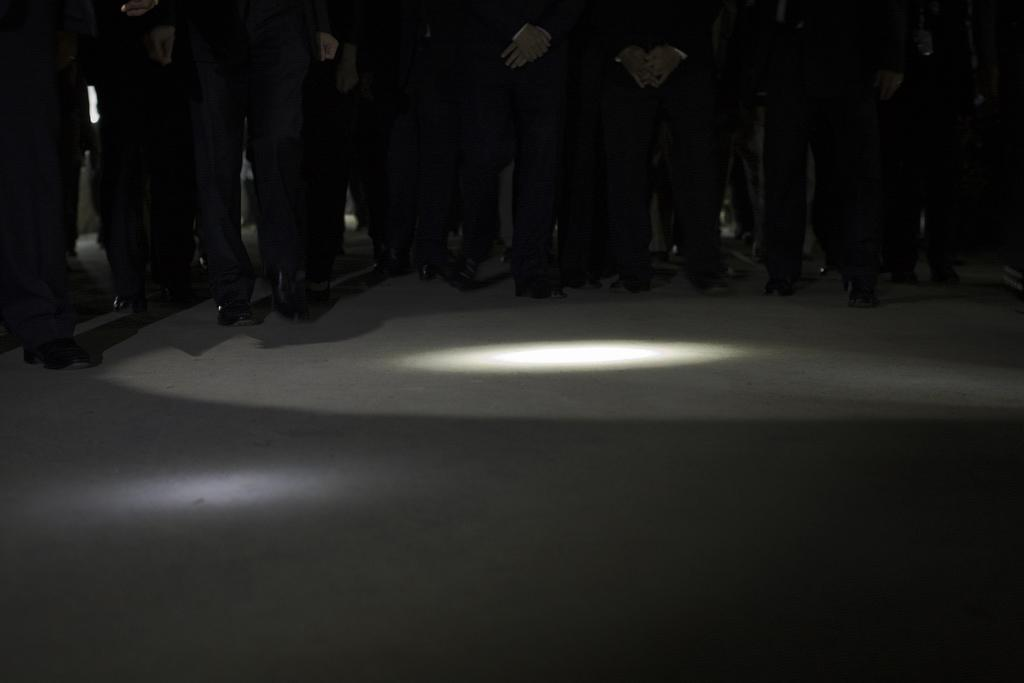How many people are present in the image? There are many people in the image. What are the people wearing on their feet? The people are wearing shoes. Can you describe the source of light in the image? There is a light in the image. What type of stitch is used to sew the floor in the image? There is no mention of a floor or stitching in the image; it only features people and a light source. 